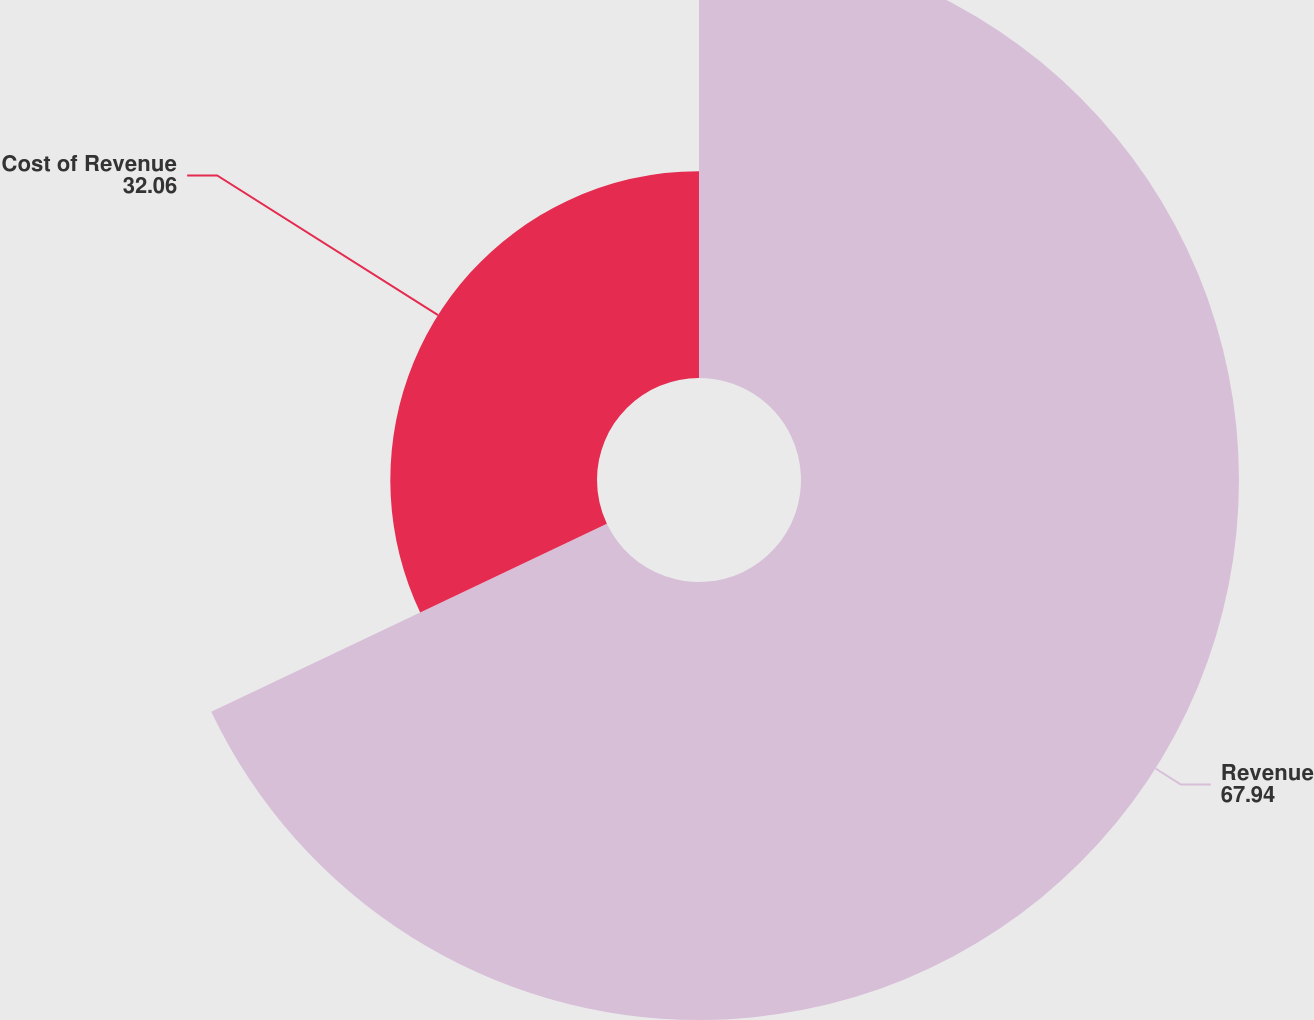Convert chart to OTSL. <chart><loc_0><loc_0><loc_500><loc_500><pie_chart><fcel>Revenue<fcel>Cost of Revenue<nl><fcel>67.94%<fcel>32.06%<nl></chart> 